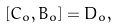<formula> <loc_0><loc_0><loc_500><loc_500>[ C _ { o } , B _ { o } ] = D _ { o } ,</formula> 